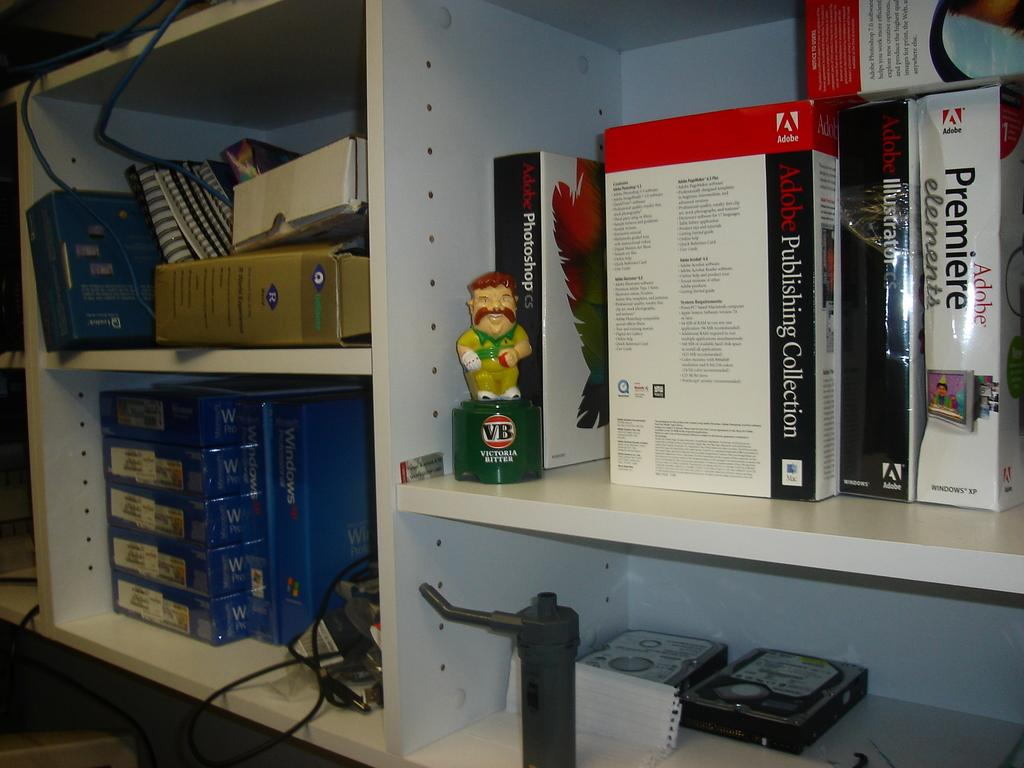<image>
Share a concise interpretation of the image provided. a few shelves, one has a Adobe Premiere elements book and VB decanter on it. 